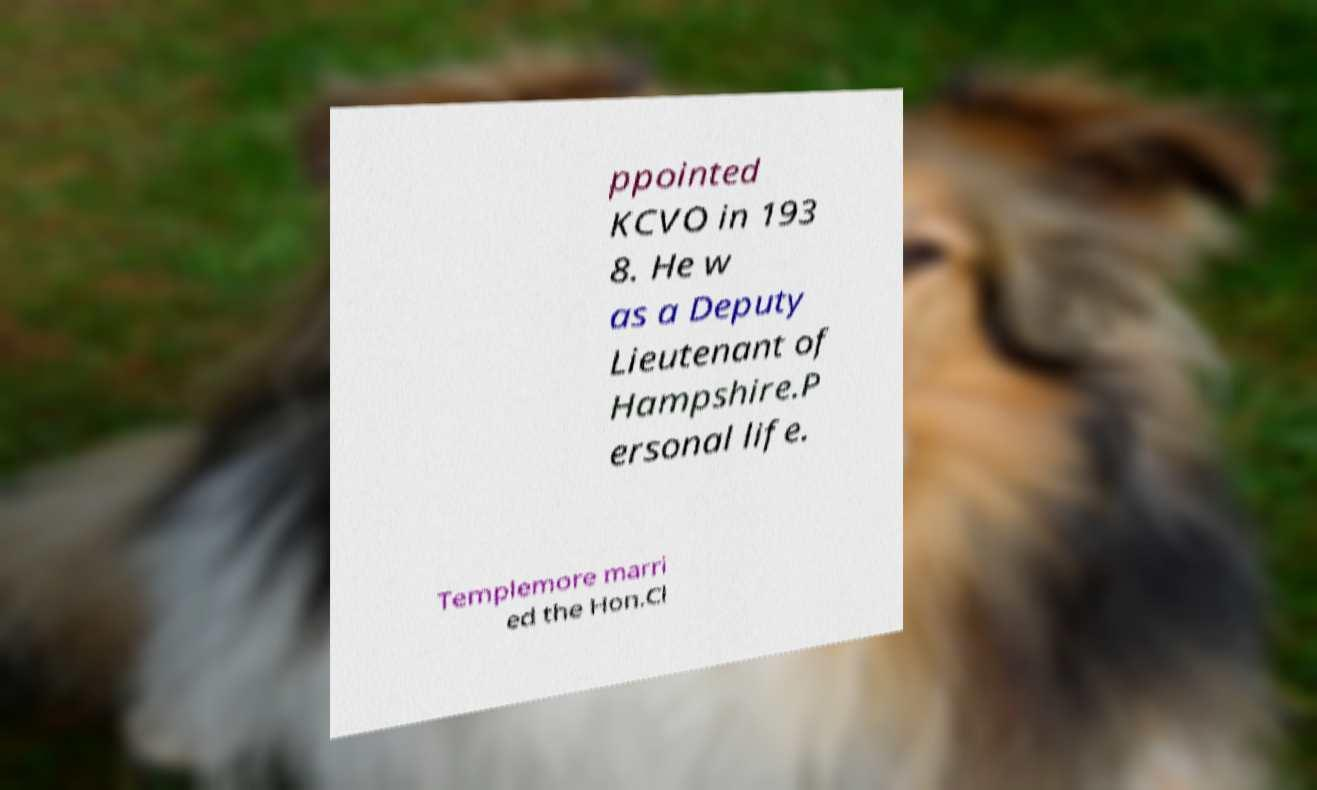There's text embedded in this image that I need extracted. Can you transcribe it verbatim? ppointed KCVO in 193 8. He w as a Deputy Lieutenant of Hampshire.P ersonal life. Templemore marri ed the Hon.Cl 